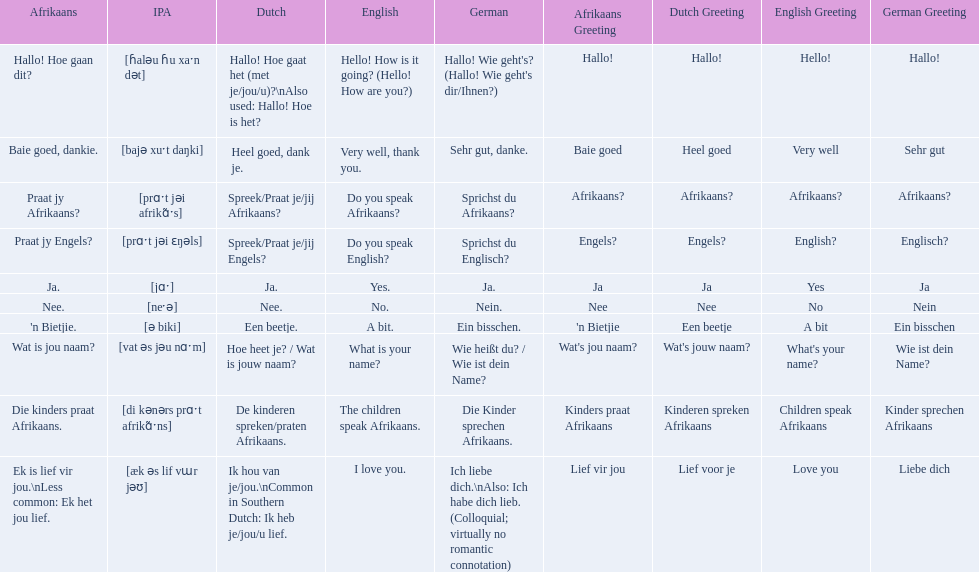What are all of the afrikaans phrases in the list? Hallo! Hoe gaan dit?, Baie goed, dankie., Praat jy Afrikaans?, Praat jy Engels?, Ja., Nee., 'n Bietjie., Wat is jou naam?, Die kinders praat Afrikaans., Ek is lief vir jou.\nLess common: Ek het jou lief. What is the english translation of each phrase? Hello! How is it going? (Hello! How are you?), Very well, thank you., Do you speak Afrikaans?, Do you speak English?, Yes., No., A bit., What is your name?, The children speak Afrikaans., I love you. And which afrikaans phrase translated to do you speak afrikaans? Praat jy Afrikaans?. 